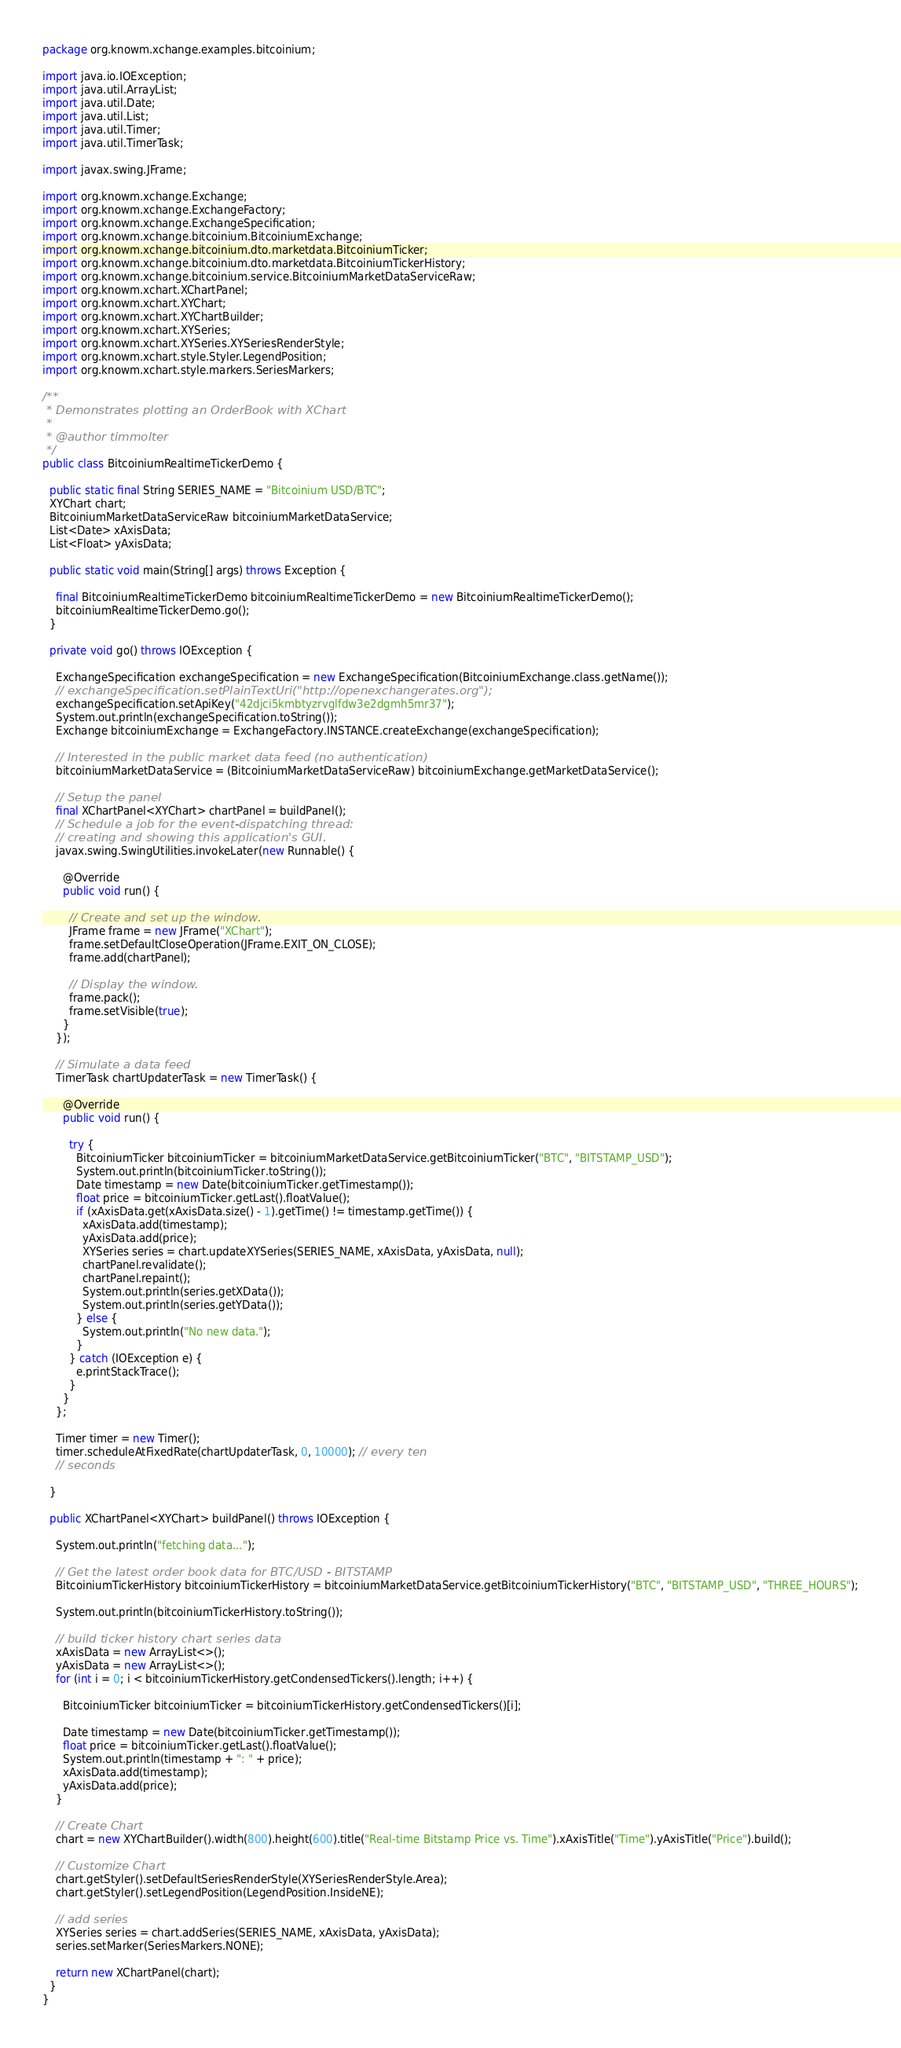<code> <loc_0><loc_0><loc_500><loc_500><_Java_>package org.knowm.xchange.examples.bitcoinium;

import java.io.IOException;
import java.util.ArrayList;
import java.util.Date;
import java.util.List;
import java.util.Timer;
import java.util.TimerTask;

import javax.swing.JFrame;

import org.knowm.xchange.Exchange;
import org.knowm.xchange.ExchangeFactory;
import org.knowm.xchange.ExchangeSpecification;
import org.knowm.xchange.bitcoinium.BitcoiniumExchange;
import org.knowm.xchange.bitcoinium.dto.marketdata.BitcoiniumTicker;
import org.knowm.xchange.bitcoinium.dto.marketdata.BitcoiniumTickerHistory;
import org.knowm.xchange.bitcoinium.service.BitcoiniumMarketDataServiceRaw;
import org.knowm.xchart.XChartPanel;
import org.knowm.xchart.XYChart;
import org.knowm.xchart.XYChartBuilder;
import org.knowm.xchart.XYSeries;
import org.knowm.xchart.XYSeries.XYSeriesRenderStyle;
import org.knowm.xchart.style.Styler.LegendPosition;
import org.knowm.xchart.style.markers.SeriesMarkers;

/**
 * Demonstrates plotting an OrderBook with XChart
 *
 * @author timmolter
 */
public class BitcoiniumRealtimeTickerDemo {

  public static final String SERIES_NAME = "Bitcoinium USD/BTC";
  XYChart chart;
  BitcoiniumMarketDataServiceRaw bitcoiniumMarketDataService;
  List<Date> xAxisData;
  List<Float> yAxisData;

  public static void main(String[] args) throws Exception {

    final BitcoiniumRealtimeTickerDemo bitcoiniumRealtimeTickerDemo = new BitcoiniumRealtimeTickerDemo();
    bitcoiniumRealtimeTickerDemo.go();
  }

  private void go() throws IOException {

    ExchangeSpecification exchangeSpecification = new ExchangeSpecification(BitcoiniumExchange.class.getName());
    // exchangeSpecification.setPlainTextUri("http://openexchangerates.org");
    exchangeSpecification.setApiKey("42djci5kmbtyzrvglfdw3e2dgmh5mr37");
    System.out.println(exchangeSpecification.toString());
    Exchange bitcoiniumExchange = ExchangeFactory.INSTANCE.createExchange(exchangeSpecification);

    // Interested in the public market data feed (no authentication)
    bitcoiniumMarketDataService = (BitcoiniumMarketDataServiceRaw) bitcoiniumExchange.getMarketDataService();

    // Setup the panel
    final XChartPanel<XYChart> chartPanel = buildPanel();
    // Schedule a job for the event-dispatching thread:
    // creating and showing this application's GUI.
    javax.swing.SwingUtilities.invokeLater(new Runnable() {

      @Override
      public void run() {

        // Create and set up the window.
        JFrame frame = new JFrame("XChart");
        frame.setDefaultCloseOperation(JFrame.EXIT_ON_CLOSE);
        frame.add(chartPanel);

        // Display the window.
        frame.pack();
        frame.setVisible(true);
      }
    });

    // Simulate a data feed
    TimerTask chartUpdaterTask = new TimerTask() {

      @Override
      public void run() {

        try {
          BitcoiniumTicker bitcoiniumTicker = bitcoiniumMarketDataService.getBitcoiniumTicker("BTC", "BITSTAMP_USD");
          System.out.println(bitcoiniumTicker.toString());
          Date timestamp = new Date(bitcoiniumTicker.getTimestamp());
          float price = bitcoiniumTicker.getLast().floatValue();
          if (xAxisData.get(xAxisData.size() - 1).getTime() != timestamp.getTime()) {
            xAxisData.add(timestamp);
            yAxisData.add(price);
            XYSeries series = chart.updateXYSeries(SERIES_NAME, xAxisData, yAxisData, null);
            chartPanel.revalidate();
            chartPanel.repaint();
            System.out.println(series.getXData());
            System.out.println(series.getYData());
          } else {
            System.out.println("No new data.");
          }
        } catch (IOException e) {
          e.printStackTrace();
        }
      }
    };

    Timer timer = new Timer();
    timer.scheduleAtFixedRate(chartUpdaterTask, 0, 10000); // every ten
    // seconds

  }

  public XChartPanel<XYChart> buildPanel() throws IOException {

    System.out.println("fetching data...");

    // Get the latest order book data for BTC/USD - BITSTAMP
    BitcoiniumTickerHistory bitcoiniumTickerHistory = bitcoiniumMarketDataService.getBitcoiniumTickerHistory("BTC", "BITSTAMP_USD", "THREE_HOURS");

    System.out.println(bitcoiniumTickerHistory.toString());

    // build ticker history chart series data
    xAxisData = new ArrayList<>();
    yAxisData = new ArrayList<>();
    for (int i = 0; i < bitcoiniumTickerHistory.getCondensedTickers().length; i++) {

      BitcoiniumTicker bitcoiniumTicker = bitcoiniumTickerHistory.getCondensedTickers()[i];

      Date timestamp = new Date(bitcoiniumTicker.getTimestamp());
      float price = bitcoiniumTicker.getLast().floatValue();
      System.out.println(timestamp + ": " + price);
      xAxisData.add(timestamp);
      yAxisData.add(price);
    }

    // Create Chart
    chart = new XYChartBuilder().width(800).height(600).title("Real-time Bitstamp Price vs. Time").xAxisTitle("Time").yAxisTitle("Price").build();

    // Customize Chart
    chart.getStyler().setDefaultSeriesRenderStyle(XYSeriesRenderStyle.Area);
    chart.getStyler().setLegendPosition(LegendPosition.InsideNE);

    // add series
    XYSeries series = chart.addSeries(SERIES_NAME, xAxisData, yAxisData);
    series.setMarker(SeriesMarkers.NONE);

    return new XChartPanel(chart);
  }
}
</code> 